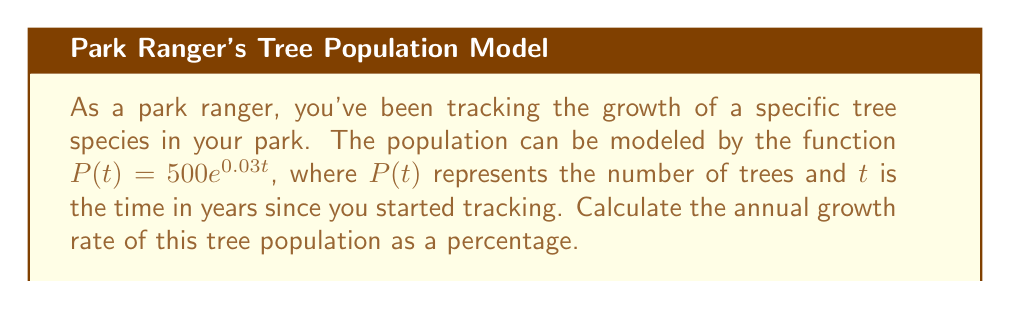Help me with this question. To find the annual growth rate, we need to follow these steps:

1) The function given is an exponential growth model:
   $P(t) = 500e^{0.03t}$

2) In exponential growth models of the form $P(t) = P_0e^{rt}$, $r$ represents the continuous growth rate.

3) In our function, $r = 0.03$

4) However, this is the continuous growth rate. To convert it to an annual percentage growth rate, we use the formula:

   Annual Growth Rate $= (e^r - 1) \times 100\%$

5) Substituting our $r$ value:
   Annual Growth Rate $= (e^{0.03} - 1) \times 100\%$

6) Calculate:
   $= (1.03045 - 1) \times 100\%$
   $= 0.03045 \times 100\%$
   $= 3.045\%$

Therefore, the annual growth rate of the tree population is approximately 3.045%.
Answer: 3.045% 